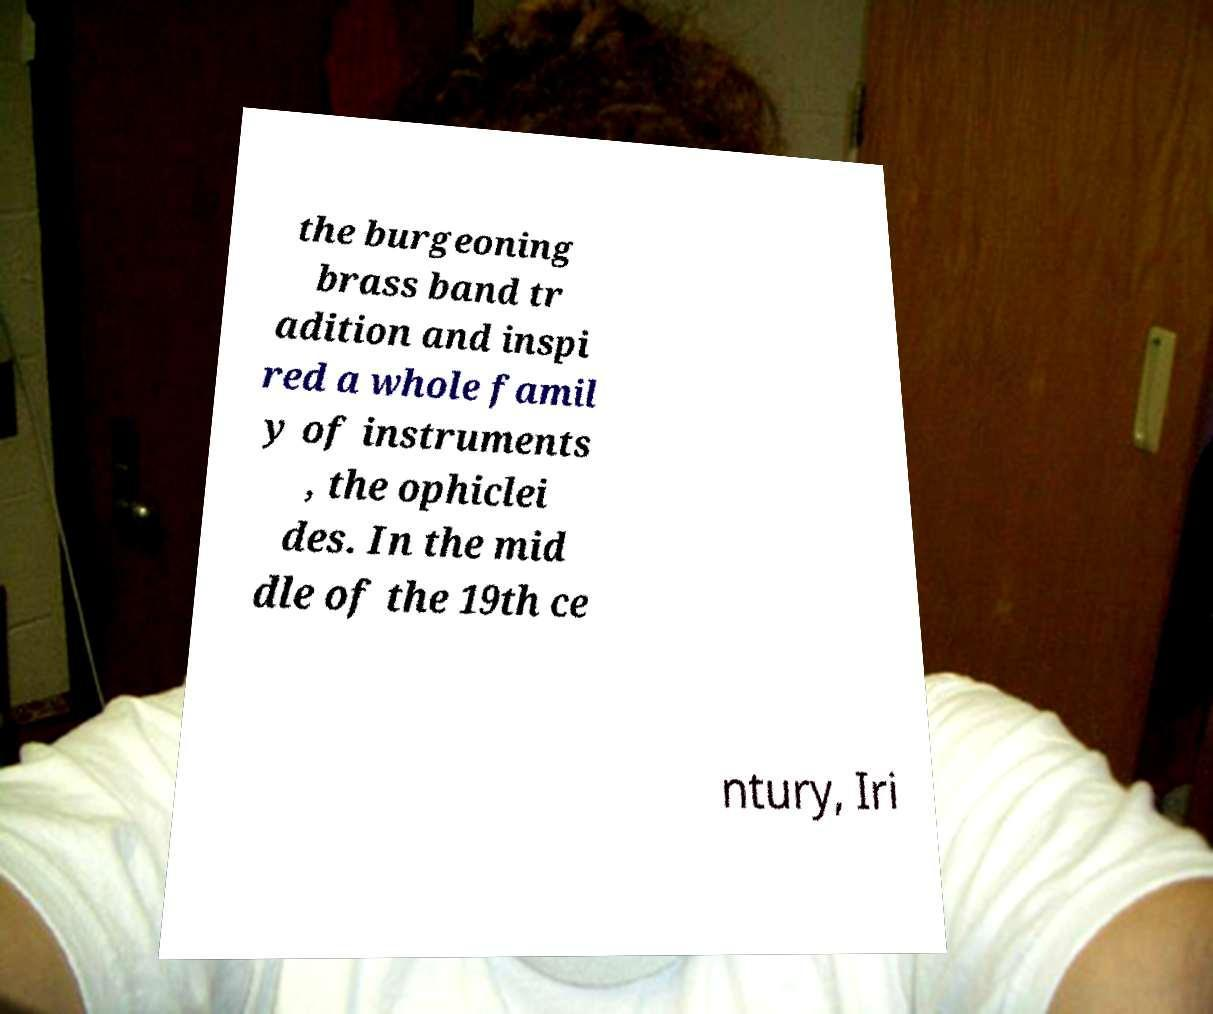Could you extract and type out the text from this image? the burgeoning brass band tr adition and inspi red a whole famil y of instruments , the ophiclei des. In the mid dle of the 19th ce ntury, Iri 